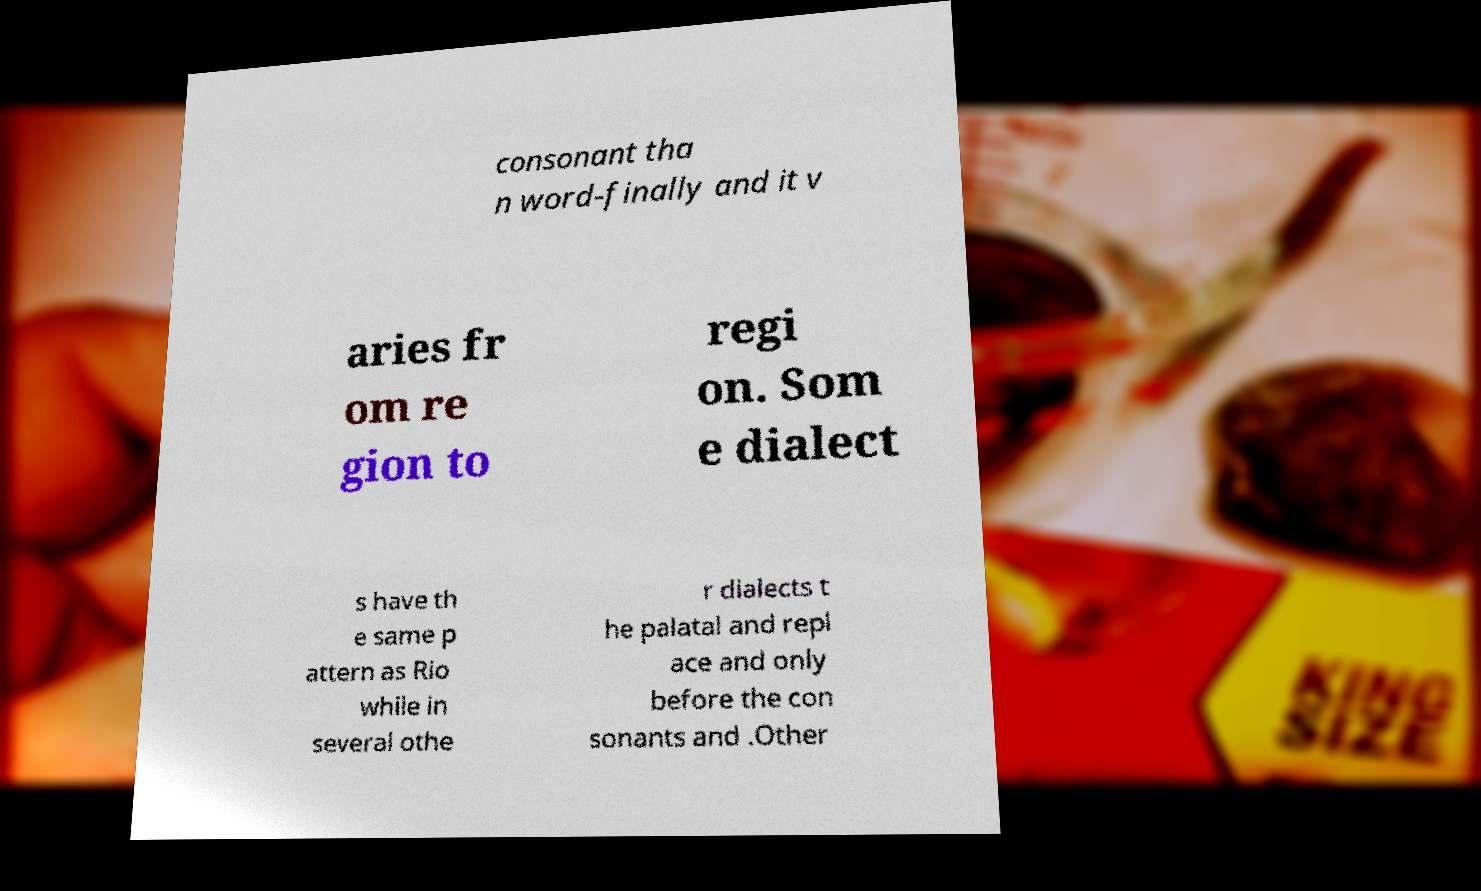Can you accurately transcribe the text from the provided image for me? consonant tha n word-finally and it v aries fr om re gion to regi on. Som e dialect s have th e same p attern as Rio while in several othe r dialects t he palatal and repl ace and only before the con sonants and .Other 